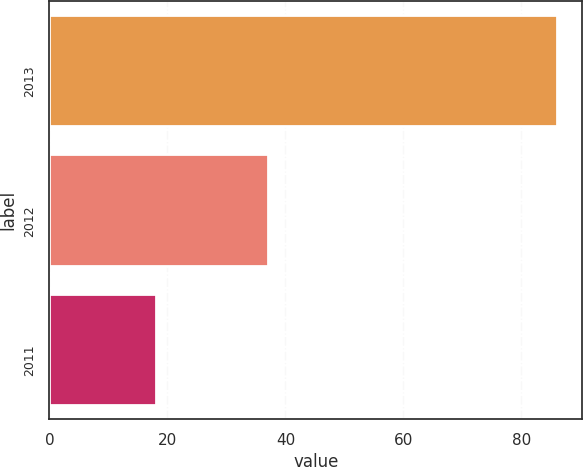<chart> <loc_0><loc_0><loc_500><loc_500><bar_chart><fcel>2013<fcel>2012<fcel>2011<nl><fcel>86<fcel>37<fcel>18<nl></chart> 